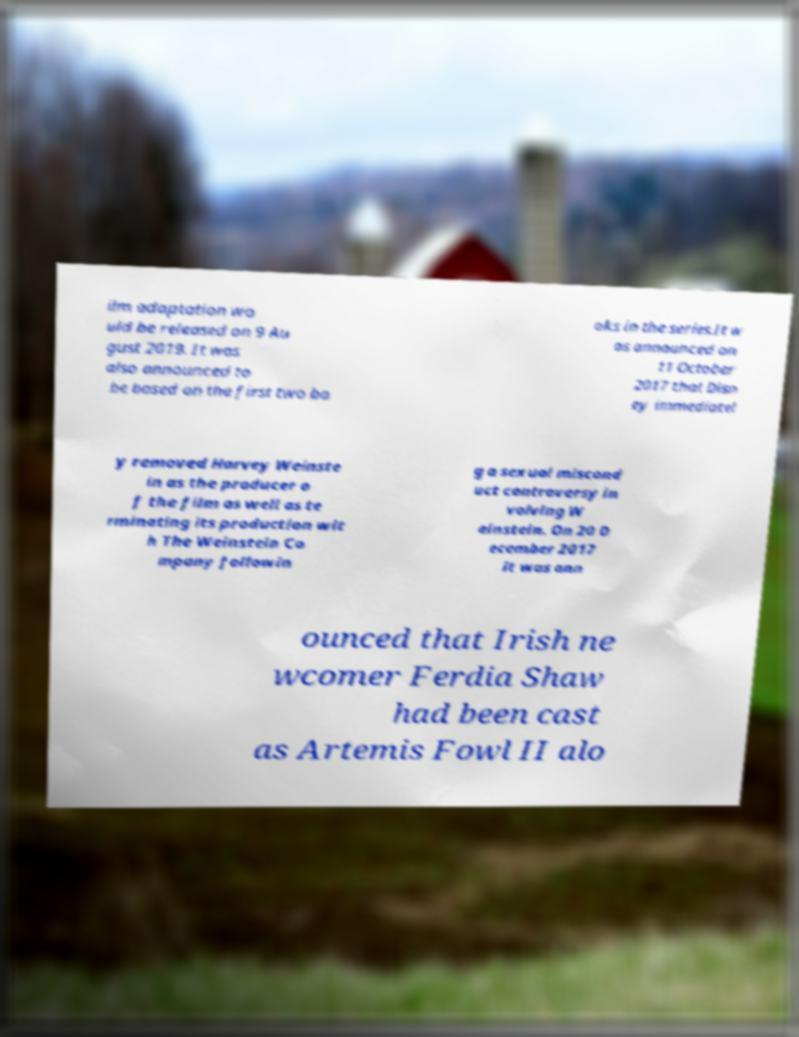I need the written content from this picture converted into text. Can you do that? ilm adaptation wo uld be released on 9 Au gust 2019. It was also announced to be based on the first two bo oks in the series.It w as announced on 11 October 2017 that Disn ey immediatel y removed Harvey Weinste in as the producer o f the film as well as te rminating its production wit h The Weinstein Co mpany followin g a sexual miscond uct controversy in volving W einstein. On 20 D ecember 2017 it was ann ounced that Irish ne wcomer Ferdia Shaw had been cast as Artemis Fowl II alo 